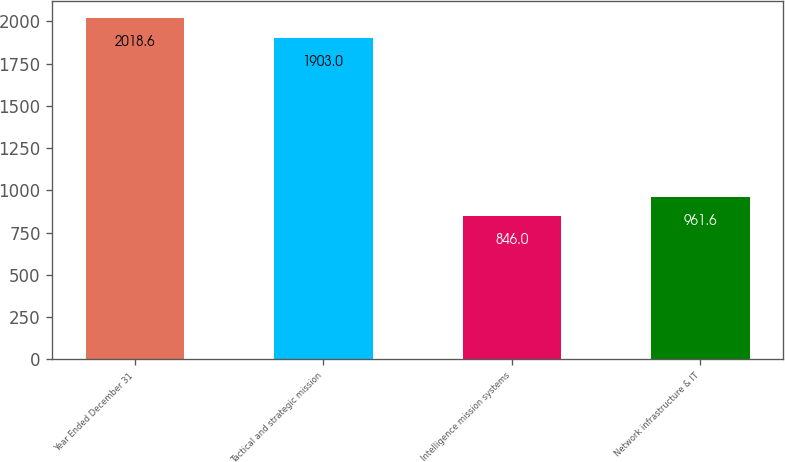Convert chart. <chart><loc_0><loc_0><loc_500><loc_500><bar_chart><fcel>Year Ended December 31<fcel>Tactical and strategic mission<fcel>Intelligence mission systems<fcel>Network infrastructure & IT<nl><fcel>2018.6<fcel>1903<fcel>846<fcel>961.6<nl></chart> 